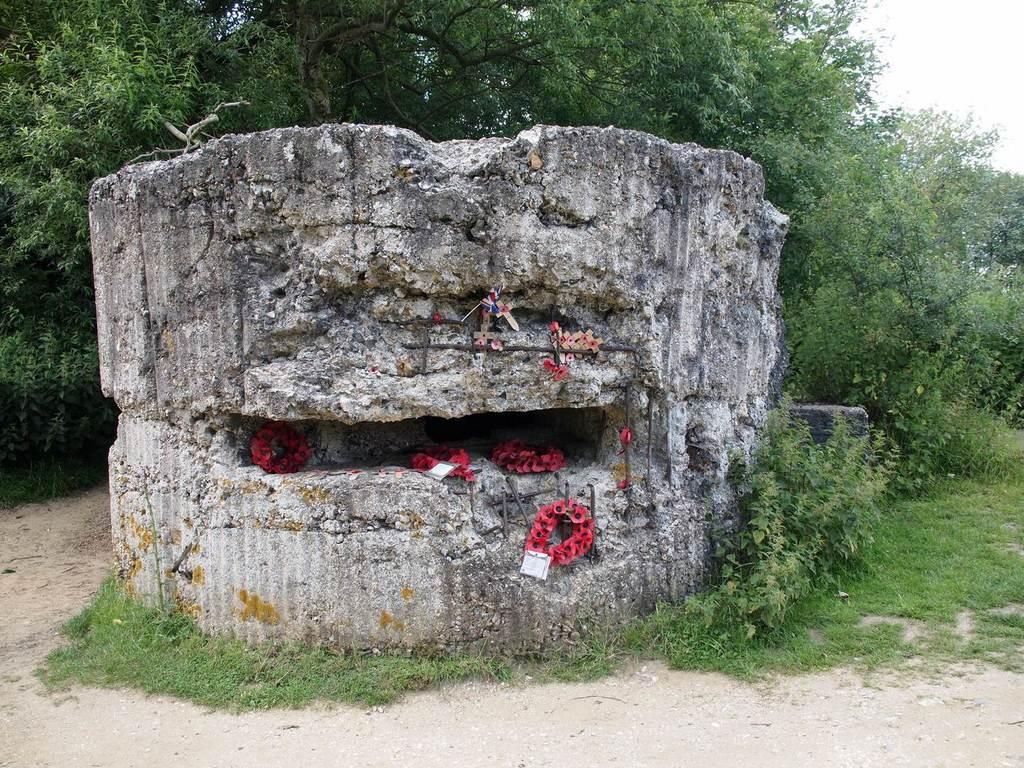What is the main subject in the middle of the image? There is a big rock in the middle of the image. What else can be seen near the big rock? There are objects near the big rock. What type of vegetation is visible in the image? There is grass and plants visible in the image. What type of man-made structure is present in the image? There is a road in the image. What other natural elements are present in the image? There are trees in the image. Can you see a beggar asking for money near the big rock in the image? There is no beggar present in the image. What type of jelly is being served on the road in the image? There is no jelly present in the image, and the road is not serving any food. 